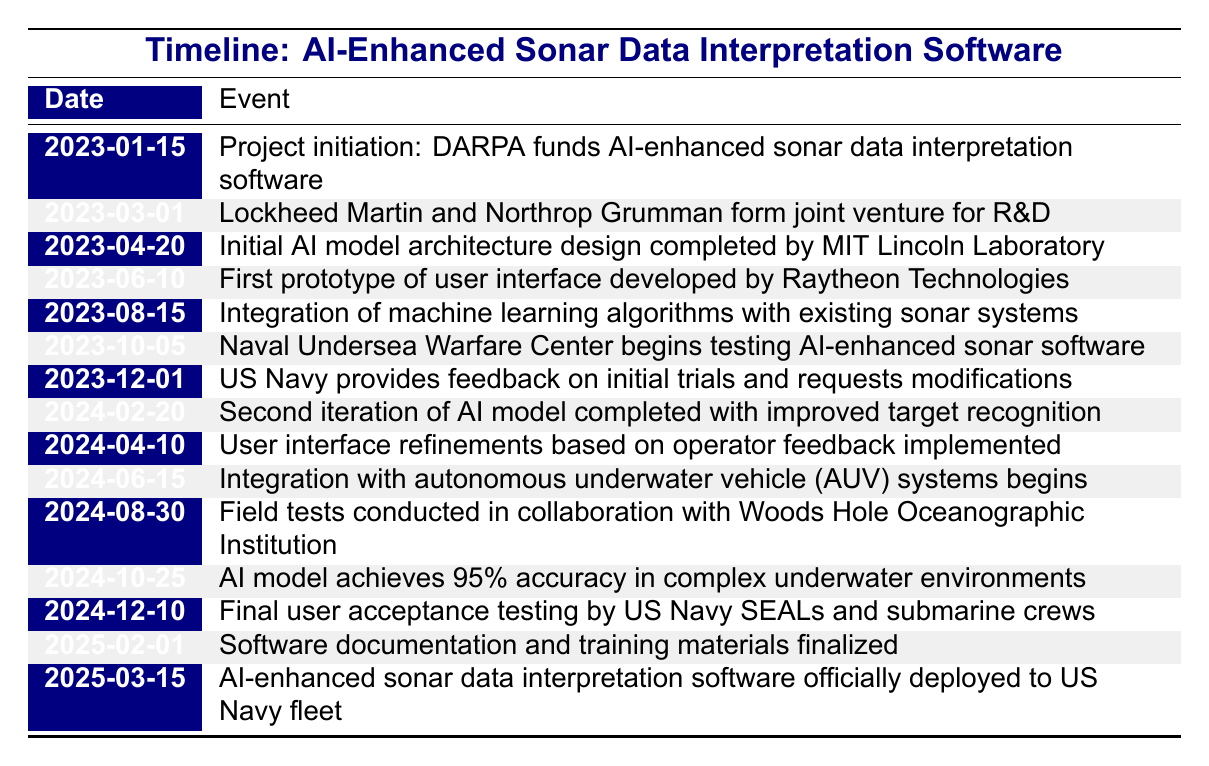What event took place on March 1, 2023? According to the timeline table, the event that took place on March 1, 2023, was the formation of a joint venture for research and development between Lockheed Martin and Northrop Grumman.
Answer: Lockheed Martin and Northrop Grumman form joint venture for R&D What is the date when the AI model achieved 95% accuracy? The timeline shows that the AI model achieved 95% accuracy on October 25, 2024.
Answer: 2024-10-25 How many months were there between the initiation of the project and the first prototype of the user interface? The project initiation date is January 15, 2023, and the first prototype date is June 10, 2023. From January to June, there are 5 months.
Answer: 5 months Did the US Navy provide feedback during the testing phase? Yes, the US Navy did provide feedback on December 1, 2023, stating they requested modifications after the initial trials.
Answer: Yes Which organization began testing the AI-enhanced sonar software? The Naval Undersea Warfare Center is the organization that began testing the AI-enhanced sonar software, as stated in the event occurring on October 5, 2023.
Answer: Naval Undersea Warfare Center What was the second iteration's primary improvement compared to the first? The second iteration of the AI model, completed on February 20, 2024, focused on improved target recognition compared to the initial AI model, which suggests an enhancement in identifying targets more effectively.
Answer: Improved target recognition How many days passed between the final user acceptance testing and the official deployment of the software? Final user acceptance testing occurred on December 10, 2024, and the software deployment was on March 15, 2025. This is a total of 95 days between these two events (counting the number of days in December (21), January (31), February (28), and up to March 15 (15)).
Answer: 95 days What event scripts took place after the user interface was developed? The timeline indicates that after the user interface was developed on June 10, 2023, integration of machine learning algorithms with existing sonar systems occurred next on August 15, 2023.
Answer: Integration of machine learning algorithms What was the purpose of the collaboration with Woods Hole Oceanographic Institution? The field tests conducted in collaboration with Woods Hole Oceanographic Institution aimed to validate the effectiveness of the AI-enhanced sonar data interpretation software, as highlighted on August 30, 2024.
Answer: Field tests for validation 